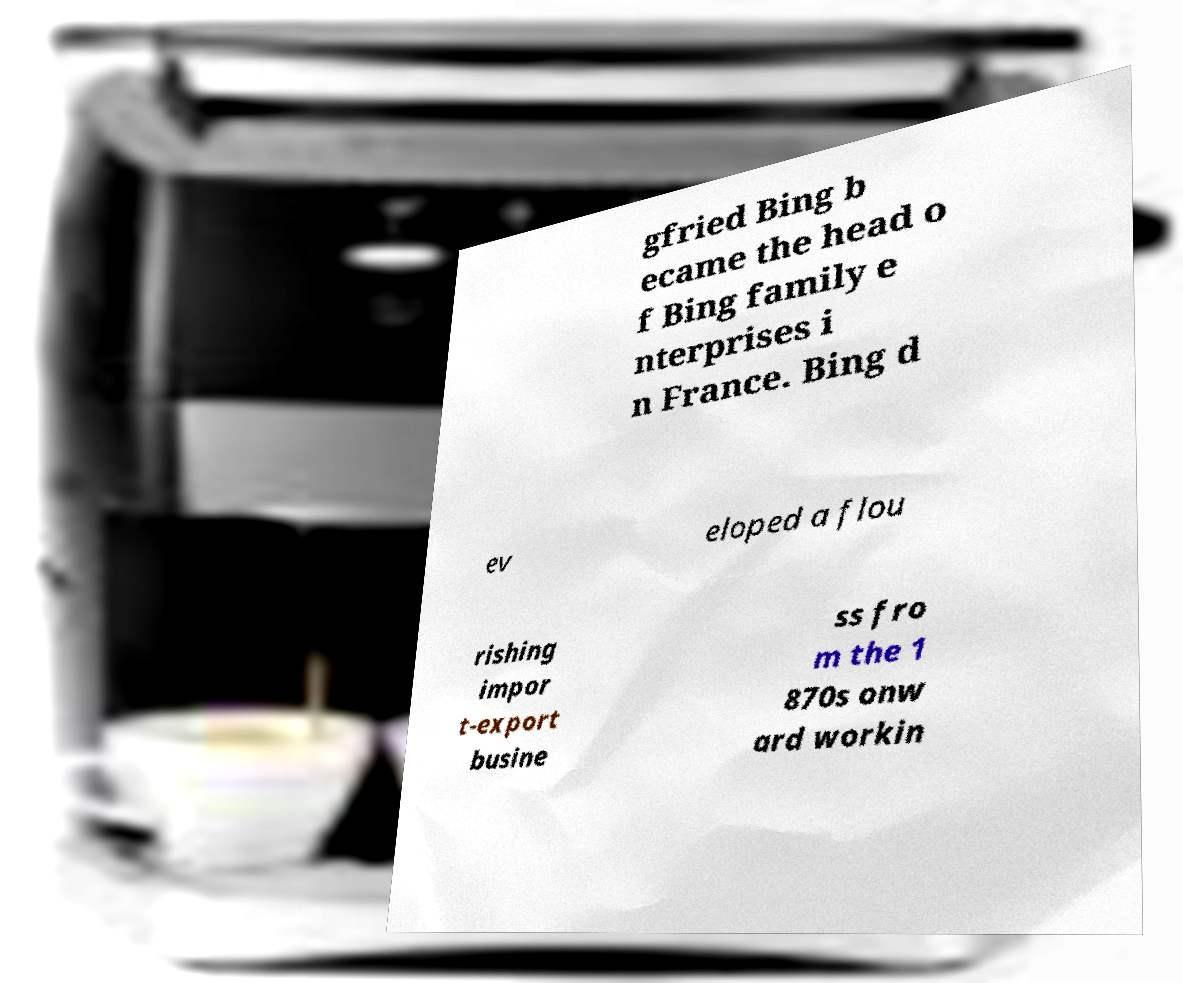For documentation purposes, I need the text within this image transcribed. Could you provide that? gfried Bing b ecame the head o f Bing family e nterprises i n France. Bing d ev eloped a flou rishing impor t-export busine ss fro m the 1 870s onw ard workin 